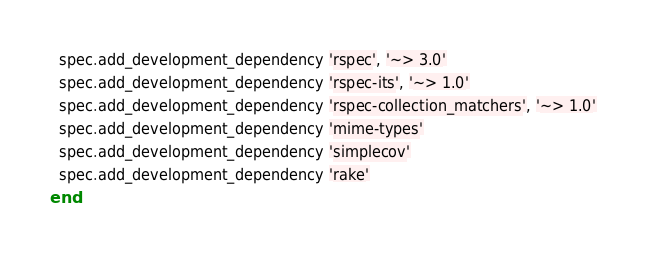Convert code to text. <code><loc_0><loc_0><loc_500><loc_500><_Ruby_>  spec.add_development_dependency 'rspec', '~> 3.0'
  spec.add_development_dependency 'rspec-its', '~> 1.0'
  spec.add_development_dependency 'rspec-collection_matchers', '~> 1.0'
  spec.add_development_dependency 'mime-types'
  spec.add_development_dependency 'simplecov'
  spec.add_development_dependency 'rake'
end
</code> 